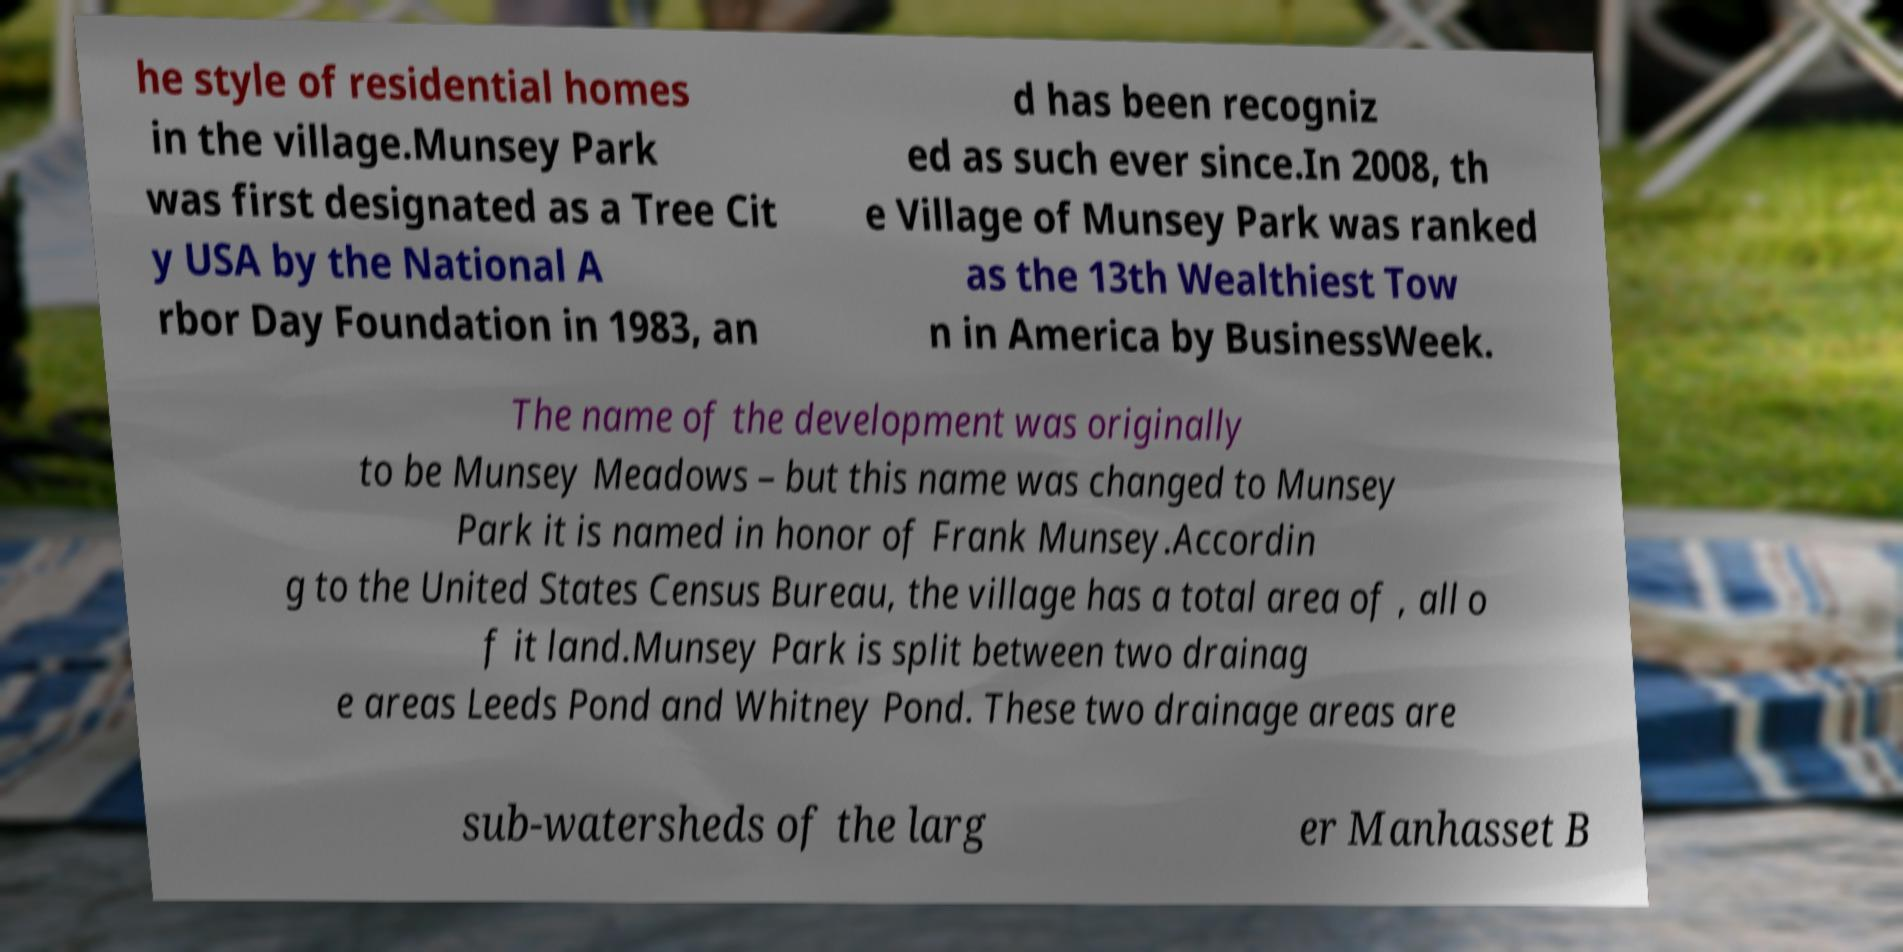Could you assist in decoding the text presented in this image and type it out clearly? he style of residential homes in the village.Munsey Park was first designated as a Tree Cit y USA by the National A rbor Day Foundation in 1983, an d has been recogniz ed as such ever since.In 2008, th e Village of Munsey Park was ranked as the 13th Wealthiest Tow n in America by BusinessWeek. The name of the development was originally to be Munsey Meadows – but this name was changed to Munsey Park it is named in honor of Frank Munsey.Accordin g to the United States Census Bureau, the village has a total area of , all o f it land.Munsey Park is split between two drainag e areas Leeds Pond and Whitney Pond. These two drainage areas are sub-watersheds of the larg er Manhasset B 